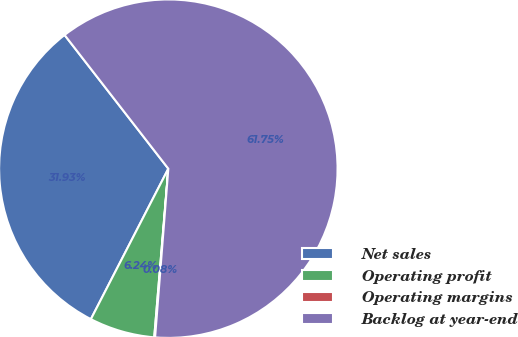Convert chart to OTSL. <chart><loc_0><loc_0><loc_500><loc_500><pie_chart><fcel>Net sales<fcel>Operating profit<fcel>Operating margins<fcel>Backlog at year-end<nl><fcel>31.93%<fcel>6.24%<fcel>0.08%<fcel>61.75%<nl></chart> 